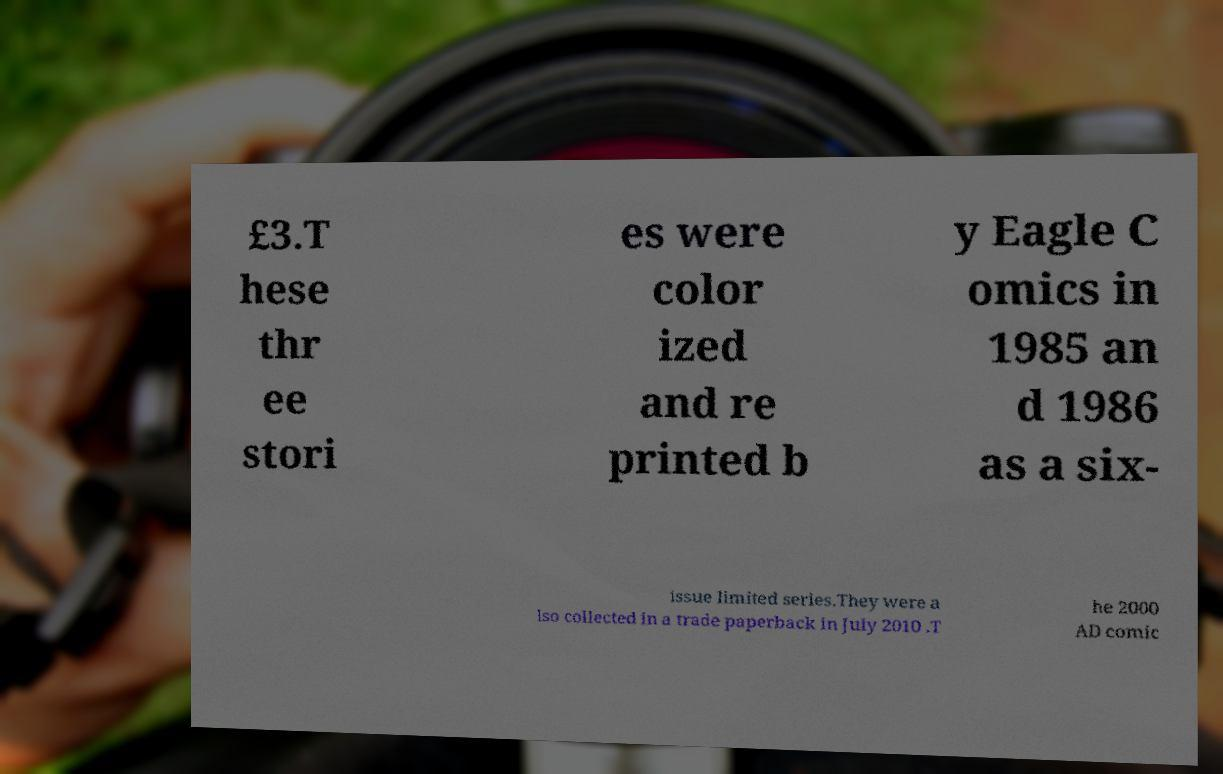Please identify and transcribe the text found in this image. £3.T hese thr ee stori es were color ized and re printed b y Eagle C omics in 1985 an d 1986 as a six- issue limited series.They were a lso collected in a trade paperback in July 2010 .T he 2000 AD comic 